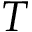Convert formula to latex. <formula><loc_0><loc_0><loc_500><loc_500>T</formula> 